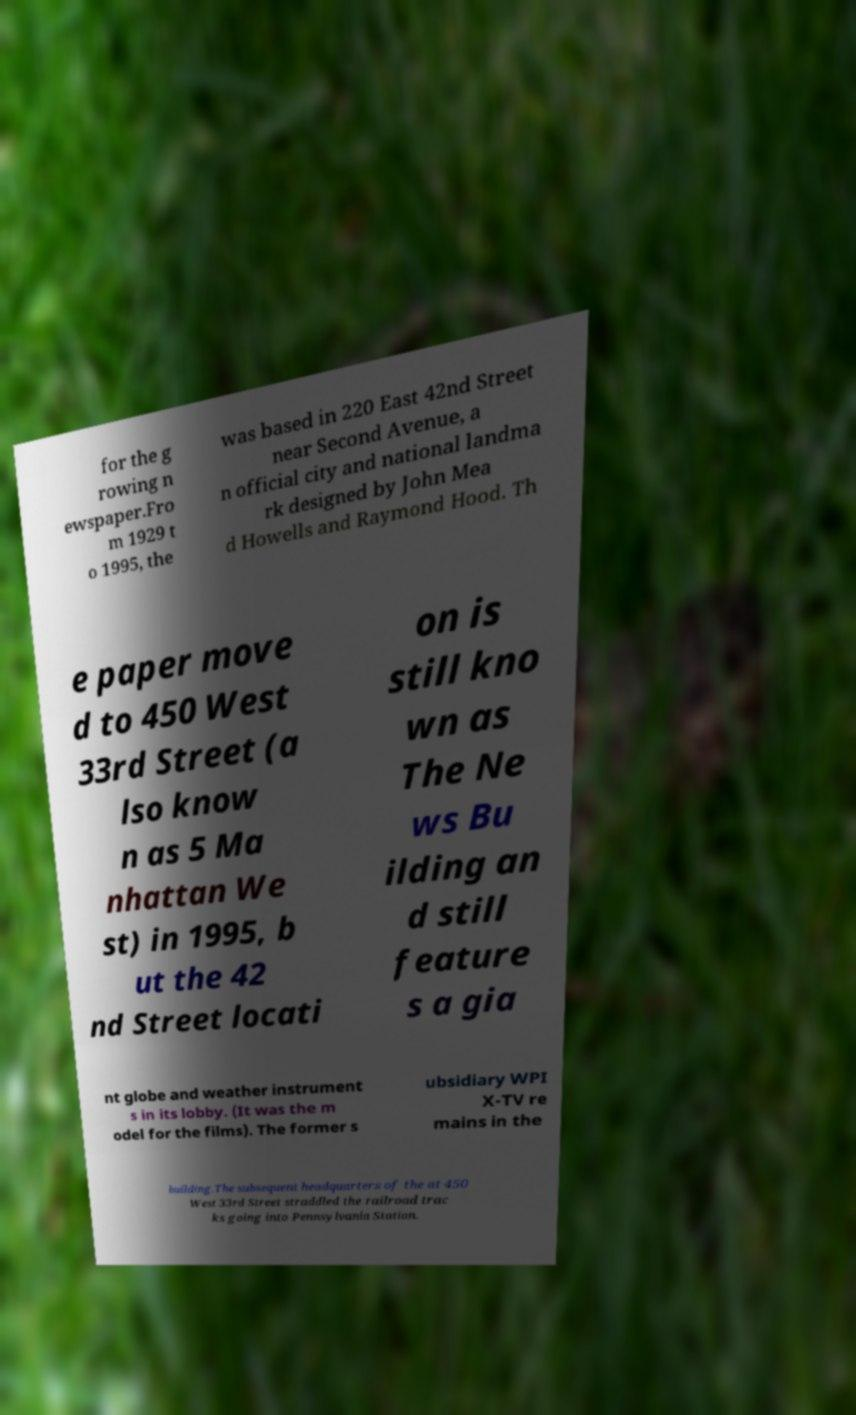Could you extract and type out the text from this image? for the g rowing n ewspaper.Fro m 1929 t o 1995, the was based in 220 East 42nd Street near Second Avenue, a n official city and national landma rk designed by John Mea d Howells and Raymond Hood. Th e paper move d to 450 West 33rd Street (a lso know n as 5 Ma nhattan We st) in 1995, b ut the 42 nd Street locati on is still kno wn as The Ne ws Bu ilding an d still feature s a gia nt globe and weather instrument s in its lobby. (It was the m odel for the films). The former s ubsidiary WPI X-TV re mains in the building.The subsequent headquarters of the at 450 West 33rd Street straddled the railroad trac ks going into Pennsylvania Station. 